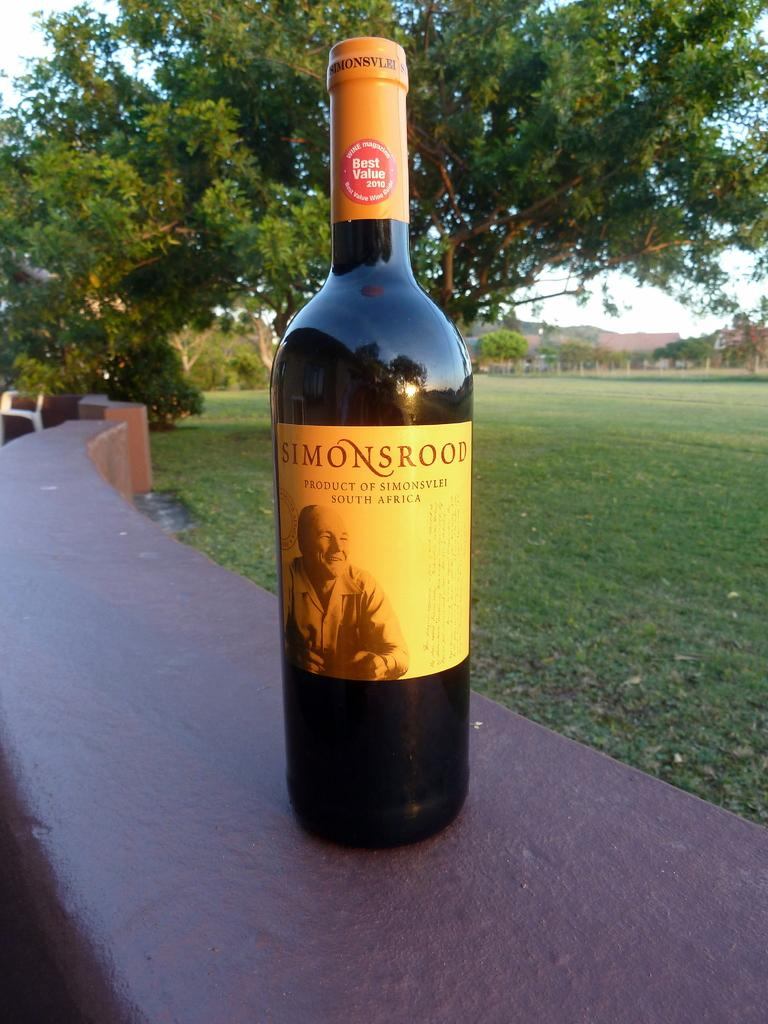<image>
Share a concise interpretation of the image provided. A bottle of Simonsrood wine from South Africa is sitting on an outdoor railing. 